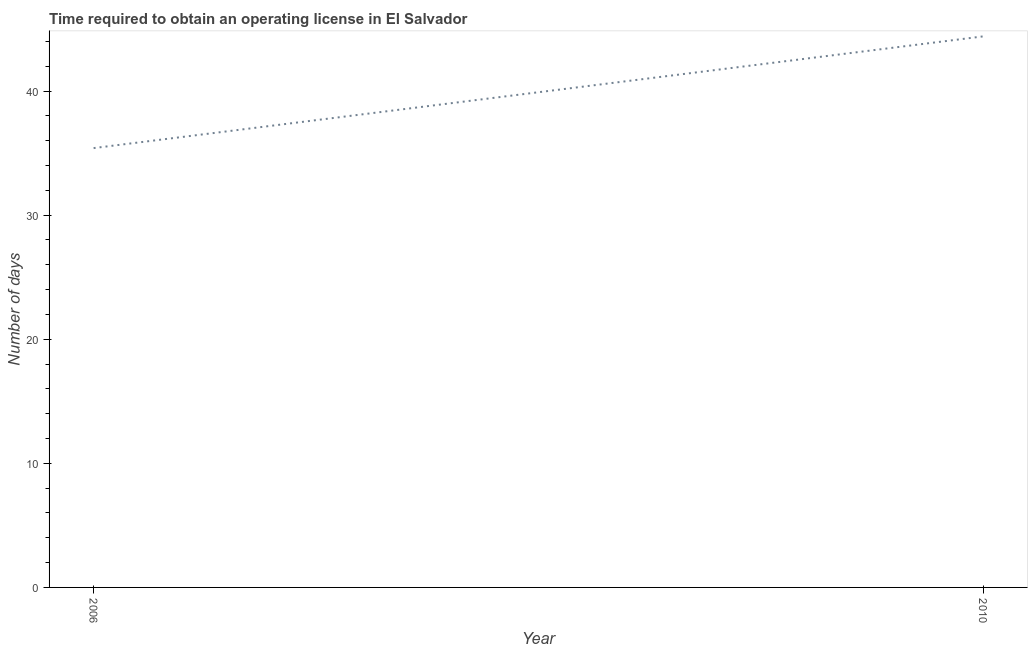What is the number of days to obtain operating license in 2010?
Make the answer very short. 44.4. Across all years, what is the maximum number of days to obtain operating license?
Your answer should be compact. 44.4. Across all years, what is the minimum number of days to obtain operating license?
Provide a succinct answer. 35.4. In which year was the number of days to obtain operating license minimum?
Offer a terse response. 2006. What is the sum of the number of days to obtain operating license?
Offer a terse response. 79.8. What is the average number of days to obtain operating license per year?
Give a very brief answer. 39.9. What is the median number of days to obtain operating license?
Make the answer very short. 39.9. In how many years, is the number of days to obtain operating license greater than 30 days?
Give a very brief answer. 2. What is the ratio of the number of days to obtain operating license in 2006 to that in 2010?
Your answer should be very brief. 0.8. Is the number of days to obtain operating license in 2006 less than that in 2010?
Keep it short and to the point. Yes. In how many years, is the number of days to obtain operating license greater than the average number of days to obtain operating license taken over all years?
Your answer should be compact. 1. How many years are there in the graph?
Your response must be concise. 2. Are the values on the major ticks of Y-axis written in scientific E-notation?
Provide a short and direct response. No. Does the graph contain grids?
Make the answer very short. No. What is the title of the graph?
Keep it short and to the point. Time required to obtain an operating license in El Salvador. What is the label or title of the Y-axis?
Ensure brevity in your answer.  Number of days. What is the Number of days in 2006?
Keep it short and to the point. 35.4. What is the Number of days in 2010?
Give a very brief answer. 44.4. What is the ratio of the Number of days in 2006 to that in 2010?
Make the answer very short. 0.8. 